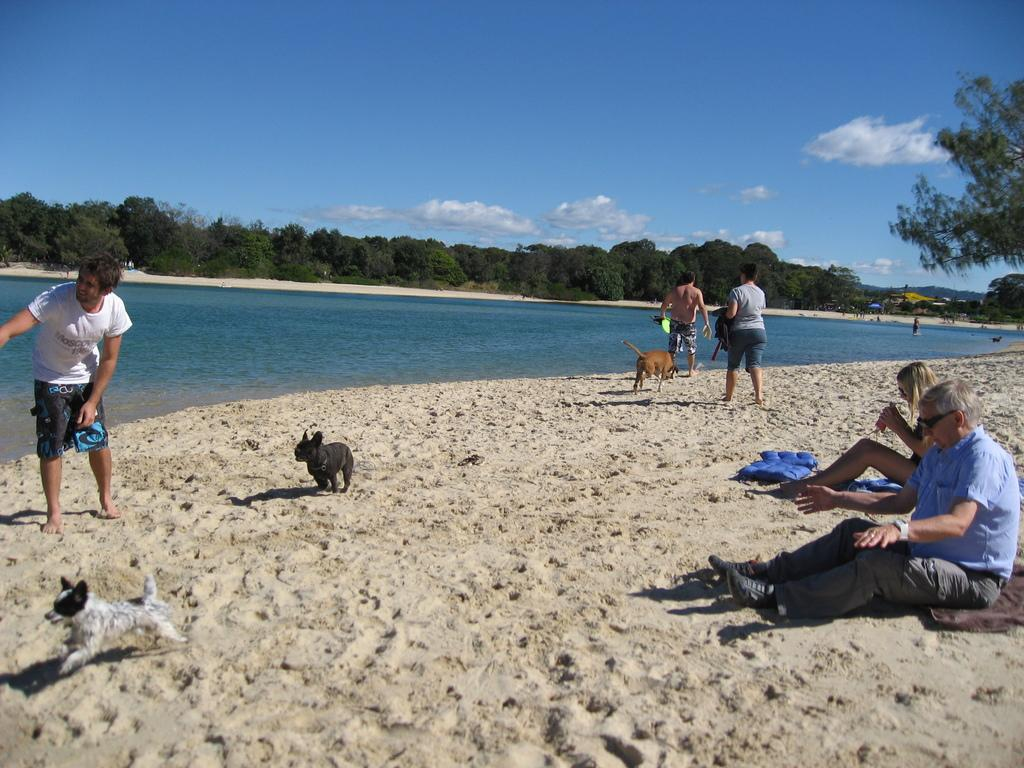What type of location is depicted in the image? There is a sea shore in the image. What animals can be seen on the sea shore? There are dogs on the sea shore. What are some people doing on the sea shore? Some people are sitting, standing, and walking on the sea shore. What natural elements can be seen in the image? There is water visible in the image, as well as trees and the sky in the background. What is the condition of the sky in the image? The sky is visible in the background of the image, and there are clouds present. What type of copper material can be seen on the train tracks in the image? There is no train or copper material present in the image; it features a sea shore with dogs, people, and natural elements. 